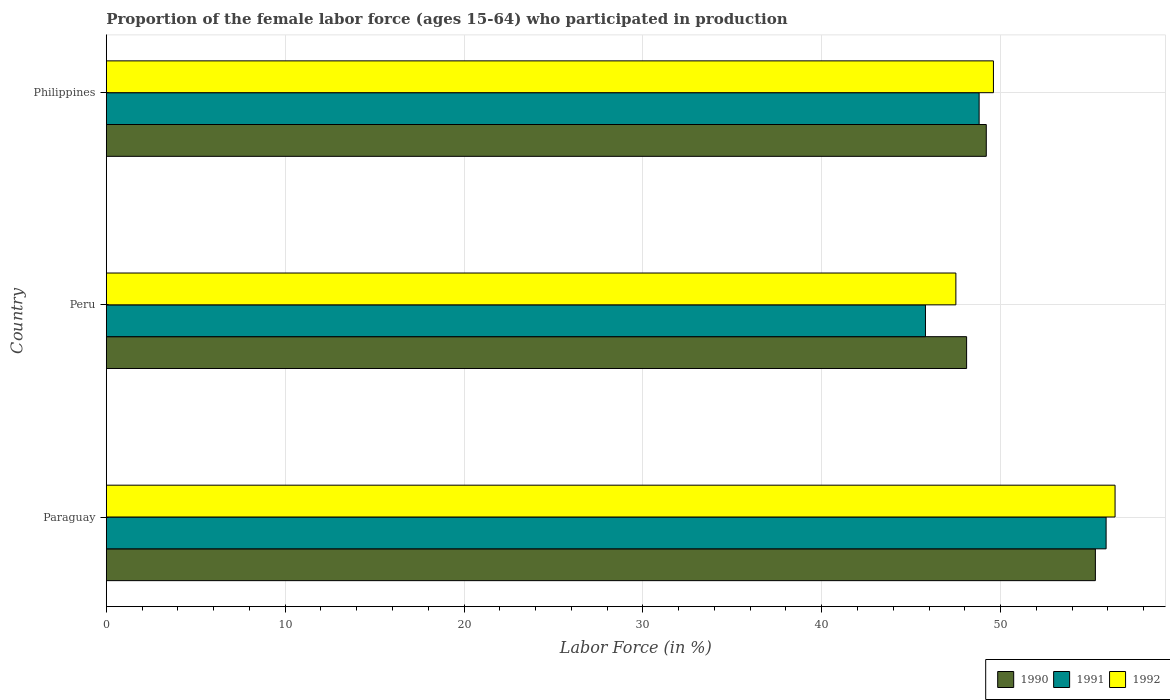Are the number of bars per tick equal to the number of legend labels?
Keep it short and to the point. Yes. How many bars are there on the 1st tick from the top?
Make the answer very short. 3. How many bars are there on the 1st tick from the bottom?
Provide a short and direct response. 3. In how many cases, is the number of bars for a given country not equal to the number of legend labels?
Give a very brief answer. 0. What is the proportion of the female labor force who participated in production in 1990 in Philippines?
Ensure brevity in your answer.  49.2. Across all countries, what is the maximum proportion of the female labor force who participated in production in 1990?
Provide a succinct answer. 55.3. Across all countries, what is the minimum proportion of the female labor force who participated in production in 1991?
Make the answer very short. 45.8. In which country was the proportion of the female labor force who participated in production in 1992 maximum?
Provide a succinct answer. Paraguay. What is the total proportion of the female labor force who participated in production in 1990 in the graph?
Give a very brief answer. 152.6. What is the difference between the proportion of the female labor force who participated in production in 1992 in Paraguay and that in Philippines?
Offer a terse response. 6.8. What is the difference between the proportion of the female labor force who participated in production in 1990 in Philippines and the proportion of the female labor force who participated in production in 1991 in Paraguay?
Provide a short and direct response. -6.7. What is the average proportion of the female labor force who participated in production in 1991 per country?
Provide a succinct answer. 50.17. What is the difference between the proportion of the female labor force who participated in production in 1991 and proportion of the female labor force who participated in production in 1992 in Philippines?
Give a very brief answer. -0.8. In how many countries, is the proportion of the female labor force who participated in production in 1991 greater than 16 %?
Keep it short and to the point. 3. What is the ratio of the proportion of the female labor force who participated in production in 1990 in Peru to that in Philippines?
Your answer should be compact. 0.98. Is the proportion of the female labor force who participated in production in 1992 in Peru less than that in Philippines?
Your response must be concise. Yes. What is the difference between the highest and the second highest proportion of the female labor force who participated in production in 1991?
Ensure brevity in your answer.  7.1. What is the difference between the highest and the lowest proportion of the female labor force who participated in production in 1990?
Provide a short and direct response. 7.2. Is the sum of the proportion of the female labor force who participated in production in 1990 in Paraguay and Peru greater than the maximum proportion of the female labor force who participated in production in 1991 across all countries?
Give a very brief answer. Yes. What does the 1st bar from the top in Philippines represents?
Offer a very short reply. 1992. How many countries are there in the graph?
Offer a very short reply. 3. What is the difference between two consecutive major ticks on the X-axis?
Provide a succinct answer. 10. Are the values on the major ticks of X-axis written in scientific E-notation?
Provide a short and direct response. No. Does the graph contain grids?
Give a very brief answer. Yes. Where does the legend appear in the graph?
Ensure brevity in your answer.  Bottom right. How many legend labels are there?
Offer a very short reply. 3. What is the title of the graph?
Offer a very short reply. Proportion of the female labor force (ages 15-64) who participated in production. Does "2015" appear as one of the legend labels in the graph?
Your answer should be very brief. No. What is the label or title of the Y-axis?
Offer a very short reply. Country. What is the Labor Force (in %) in 1990 in Paraguay?
Your answer should be compact. 55.3. What is the Labor Force (in %) of 1991 in Paraguay?
Ensure brevity in your answer.  55.9. What is the Labor Force (in %) in 1992 in Paraguay?
Offer a very short reply. 56.4. What is the Labor Force (in %) of 1990 in Peru?
Ensure brevity in your answer.  48.1. What is the Labor Force (in %) in 1991 in Peru?
Make the answer very short. 45.8. What is the Labor Force (in %) in 1992 in Peru?
Give a very brief answer. 47.5. What is the Labor Force (in %) of 1990 in Philippines?
Keep it short and to the point. 49.2. What is the Labor Force (in %) in 1991 in Philippines?
Offer a very short reply. 48.8. What is the Labor Force (in %) in 1992 in Philippines?
Offer a very short reply. 49.6. Across all countries, what is the maximum Labor Force (in %) in 1990?
Your response must be concise. 55.3. Across all countries, what is the maximum Labor Force (in %) in 1991?
Offer a very short reply. 55.9. Across all countries, what is the maximum Labor Force (in %) of 1992?
Your response must be concise. 56.4. Across all countries, what is the minimum Labor Force (in %) of 1990?
Provide a short and direct response. 48.1. Across all countries, what is the minimum Labor Force (in %) in 1991?
Offer a very short reply. 45.8. Across all countries, what is the minimum Labor Force (in %) of 1992?
Make the answer very short. 47.5. What is the total Labor Force (in %) in 1990 in the graph?
Offer a terse response. 152.6. What is the total Labor Force (in %) of 1991 in the graph?
Give a very brief answer. 150.5. What is the total Labor Force (in %) in 1992 in the graph?
Give a very brief answer. 153.5. What is the difference between the Labor Force (in %) of 1991 in Peru and that in Philippines?
Ensure brevity in your answer.  -3. What is the difference between the Labor Force (in %) in 1990 in Paraguay and the Labor Force (in %) in 1991 in Peru?
Give a very brief answer. 9.5. What is the difference between the Labor Force (in %) of 1991 in Paraguay and the Labor Force (in %) of 1992 in Peru?
Make the answer very short. 8.4. What is the difference between the Labor Force (in %) in 1991 in Paraguay and the Labor Force (in %) in 1992 in Philippines?
Ensure brevity in your answer.  6.3. What is the difference between the Labor Force (in %) of 1990 in Peru and the Labor Force (in %) of 1991 in Philippines?
Provide a short and direct response. -0.7. What is the difference between the Labor Force (in %) in 1990 in Peru and the Labor Force (in %) in 1992 in Philippines?
Your answer should be very brief. -1.5. What is the average Labor Force (in %) in 1990 per country?
Give a very brief answer. 50.87. What is the average Labor Force (in %) in 1991 per country?
Provide a short and direct response. 50.17. What is the average Labor Force (in %) of 1992 per country?
Provide a short and direct response. 51.17. What is the difference between the Labor Force (in %) of 1990 and Labor Force (in %) of 1991 in Paraguay?
Give a very brief answer. -0.6. What is the difference between the Labor Force (in %) in 1990 and Labor Force (in %) in 1992 in Paraguay?
Ensure brevity in your answer.  -1.1. What is the difference between the Labor Force (in %) of 1991 and Labor Force (in %) of 1992 in Paraguay?
Your answer should be compact. -0.5. What is the difference between the Labor Force (in %) in 1991 and Labor Force (in %) in 1992 in Peru?
Your answer should be compact. -1.7. What is the ratio of the Labor Force (in %) of 1990 in Paraguay to that in Peru?
Your response must be concise. 1.15. What is the ratio of the Labor Force (in %) in 1991 in Paraguay to that in Peru?
Keep it short and to the point. 1.22. What is the ratio of the Labor Force (in %) in 1992 in Paraguay to that in Peru?
Provide a short and direct response. 1.19. What is the ratio of the Labor Force (in %) of 1990 in Paraguay to that in Philippines?
Your answer should be very brief. 1.12. What is the ratio of the Labor Force (in %) of 1991 in Paraguay to that in Philippines?
Provide a succinct answer. 1.15. What is the ratio of the Labor Force (in %) in 1992 in Paraguay to that in Philippines?
Provide a succinct answer. 1.14. What is the ratio of the Labor Force (in %) of 1990 in Peru to that in Philippines?
Your response must be concise. 0.98. What is the ratio of the Labor Force (in %) in 1991 in Peru to that in Philippines?
Keep it short and to the point. 0.94. What is the ratio of the Labor Force (in %) of 1992 in Peru to that in Philippines?
Ensure brevity in your answer.  0.96. What is the difference between the highest and the second highest Labor Force (in %) of 1992?
Provide a short and direct response. 6.8. 